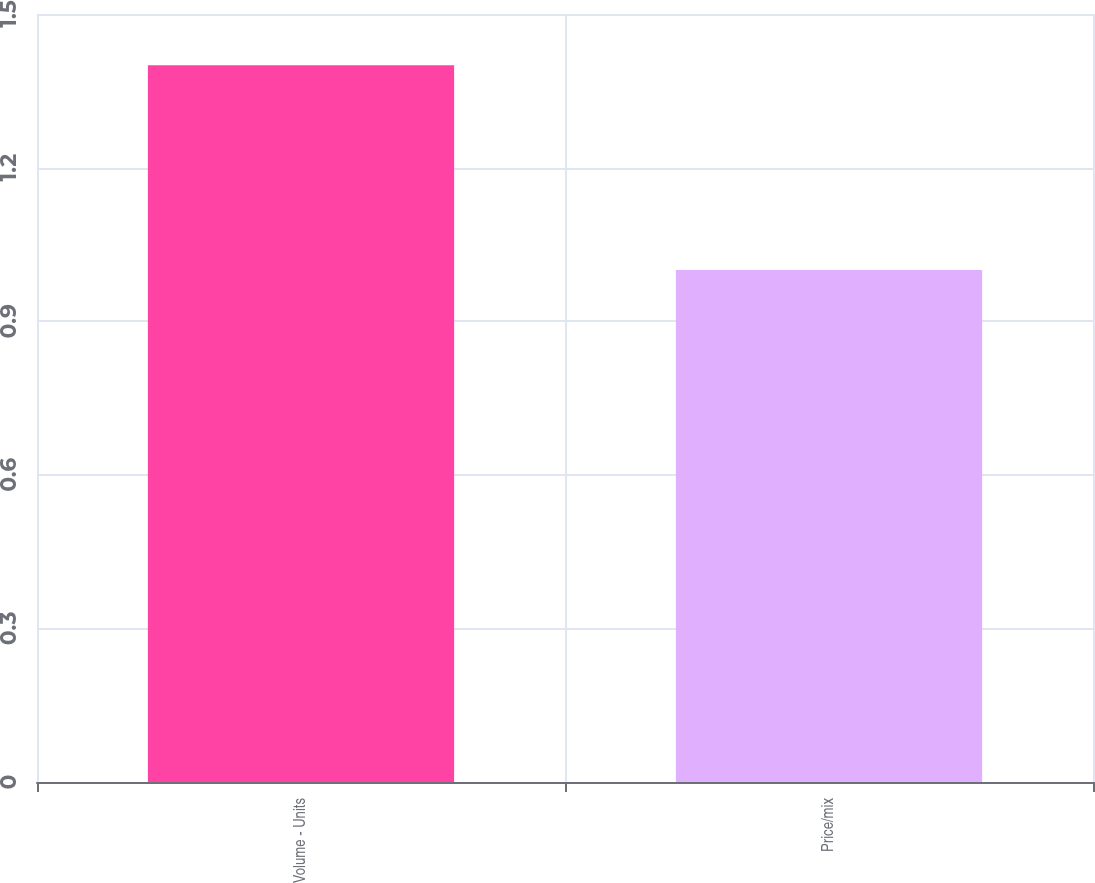<chart> <loc_0><loc_0><loc_500><loc_500><bar_chart><fcel>Volume - Units<fcel>Price/mix<nl><fcel>1.4<fcel>1<nl></chart> 